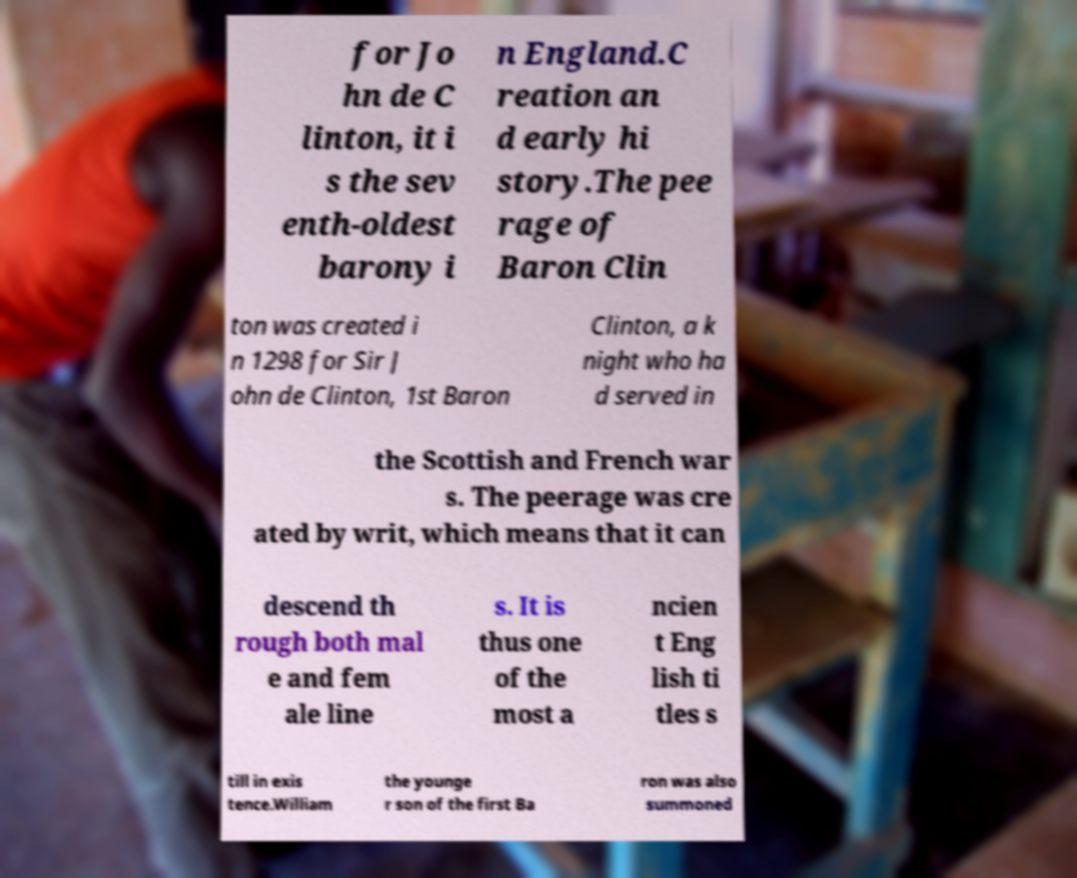There's text embedded in this image that I need extracted. Can you transcribe it verbatim? for Jo hn de C linton, it i s the sev enth-oldest barony i n England.C reation an d early hi story.The pee rage of Baron Clin ton was created i n 1298 for Sir J ohn de Clinton, 1st Baron Clinton, a k night who ha d served in the Scottish and French war s. The peerage was cre ated by writ, which means that it can descend th rough both mal e and fem ale line s. It is thus one of the most a ncien t Eng lish ti tles s till in exis tence.William the younge r son of the first Ba ron was also summoned 